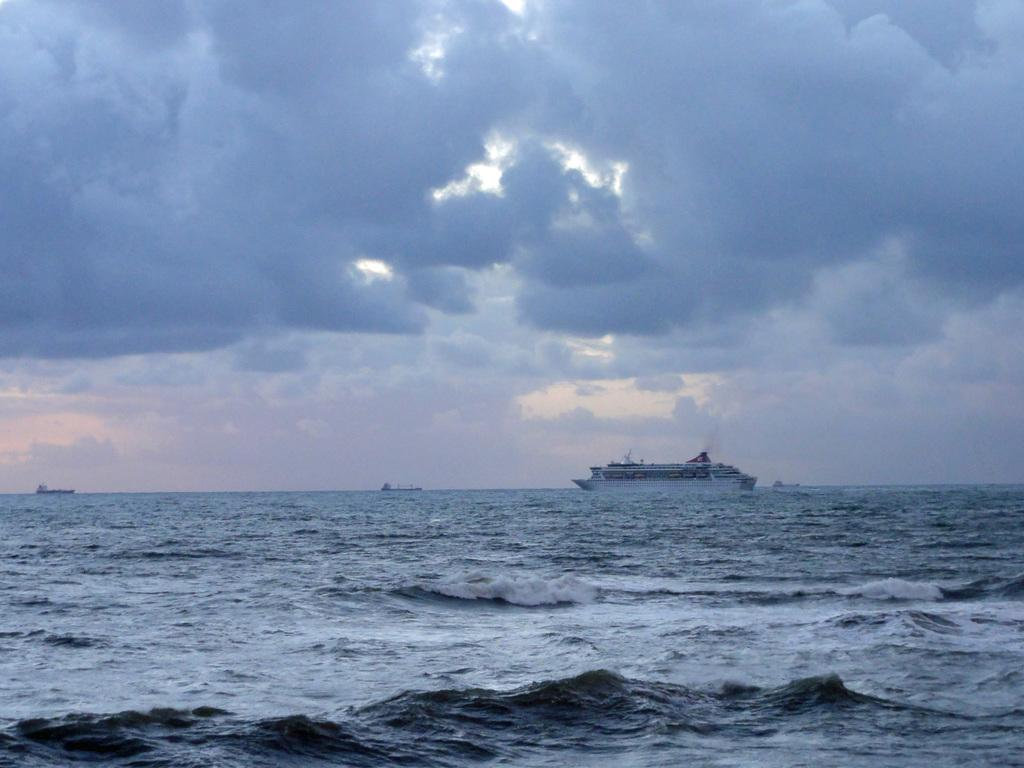What is the main subject of the image? The main subject of the image is a ship. What is the ship's location in relation to the water? The ship is floating on the water. What can be seen in the sky in the image? There are clouds in the sky. How many brothers are depicted on the ship in the image? There are no people, let alone brothers, depicted on the ship in the image. 